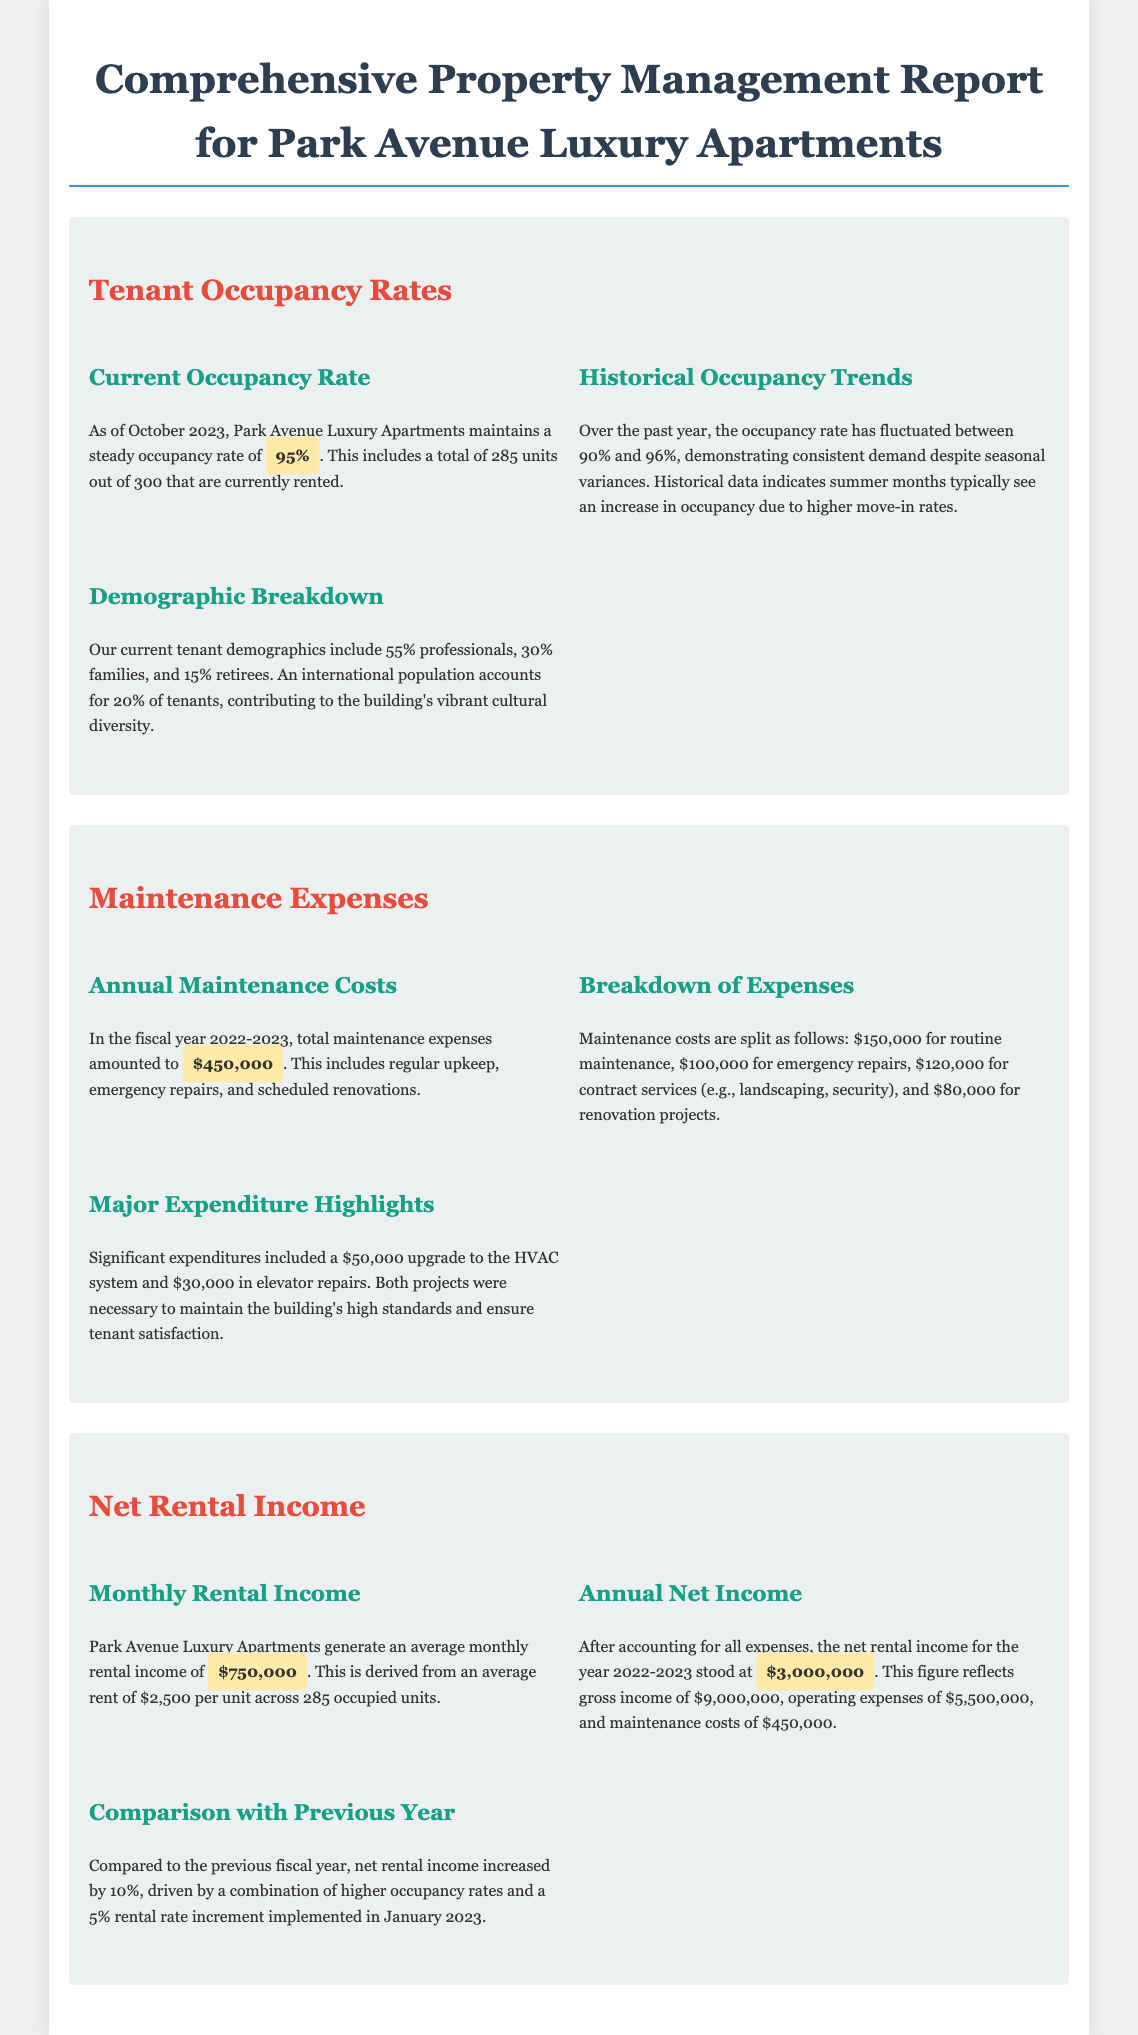What is the current occupancy rate? The current occupancy rate is found in the Tenant Occupancy Rates section, which states it is 95%.
Answer: 95% What are the total maintenance expenses for the fiscal year 2022-2023? The total maintenance expenses are specified in the Maintenance Expenses section, amounting to $450,000.
Answer: $450,000 What is the average monthly rental income? The average monthly rental income is provided in the Net Rental Income section, which mentions $750,000.
Answer: $750,000 How much did the net rental income increase by compared to the previous year? The increase in net rental income compared to the previous year is described as 10% in the document.
Answer: 10% What percentage of tenants are professionals? The demographic breakdown indicates that 55% of tenants are professionals.
Answer: 55% What was the major expenditure for the HVAC system? Details in the Maintenance Expenses section specify that the upgrade to the HVAC system cost $50,000.
Answer: $50,000 What is the annual net income for 2022-2023? The annual net income is listed in the Net Rental Income section, stating it stood at $3,000,000.
Answer: $3,000,000 Which month typically sees higher occupancy due to increased move-ins? The Historical Occupancy Trends section mentions summer months typically see an increase in occupancy.
Answer: Summer What percentage of the tenants identify as families? The demographic breakdown in the Tenant Occupancy Rates section states that 30% of tenants are families.
Answer: 30% What was the gross income for the year mentioned? The document specifies that the gross income for the year 2022-2023 was $9,000,000.
Answer: $9,000,000 